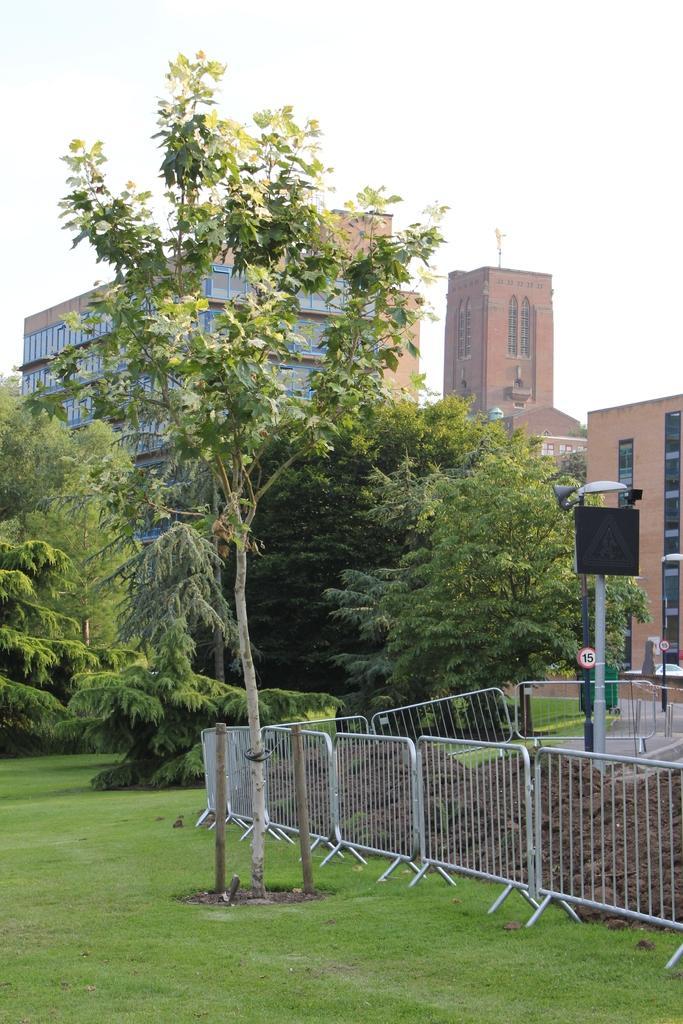How would you summarize this image in a sentence or two? In this image I can see trees, fence, poles, the grass and buildings. In the background I can see the sky. 